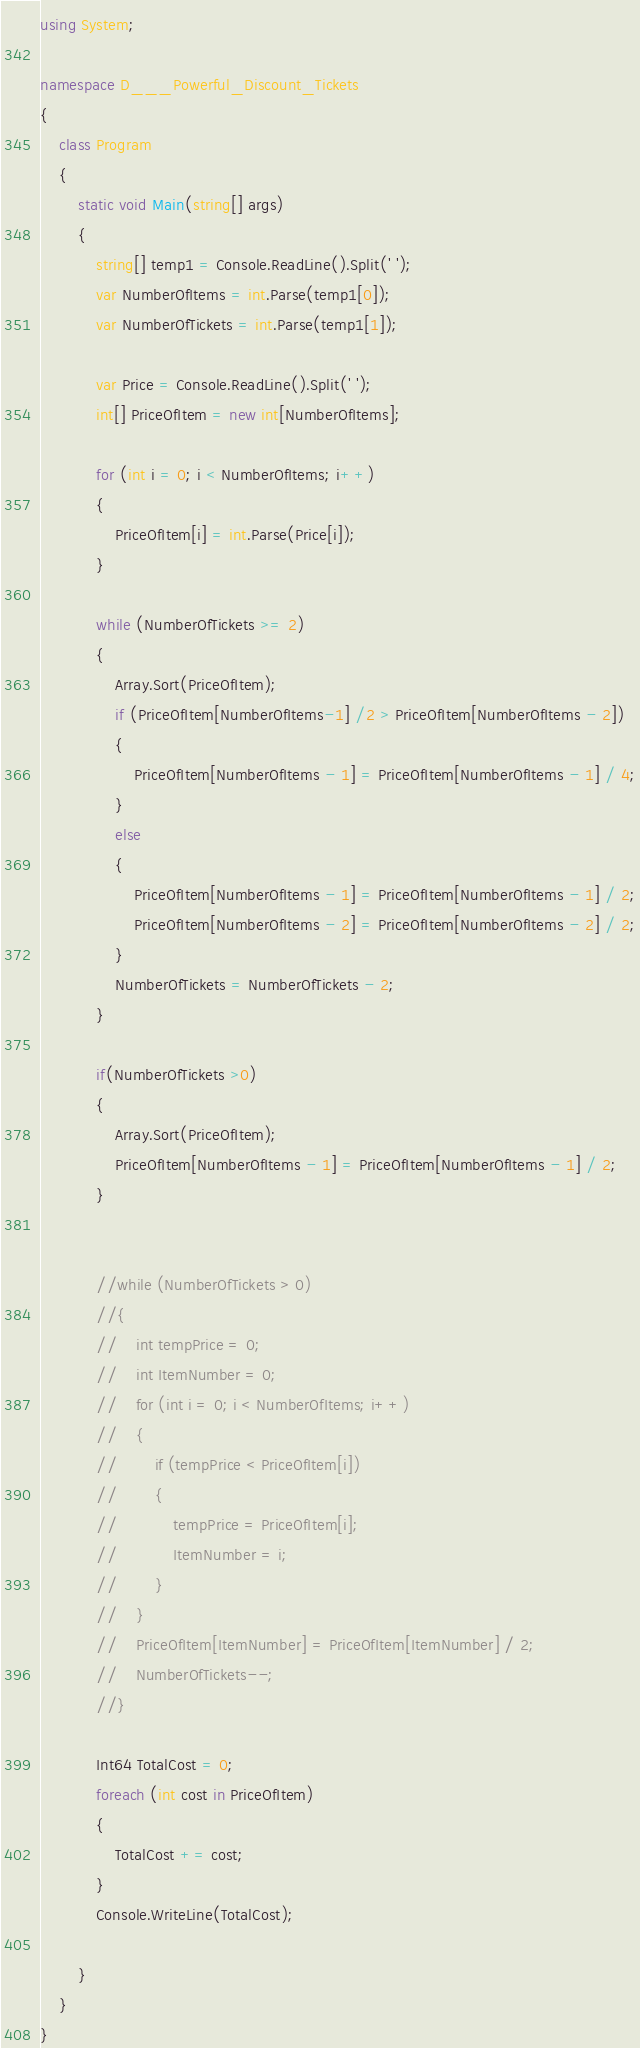Convert code to text. <code><loc_0><loc_0><loc_500><loc_500><_C#_>using System;

namespace D___Powerful_Discount_Tickets
{
    class Program
    {
        static void Main(string[] args)
        {
            string[] temp1 = Console.ReadLine().Split(' ');
            var NumberOfItems = int.Parse(temp1[0]);
            var NumberOfTickets = int.Parse(temp1[1]);

            var Price = Console.ReadLine().Split(' ');
            int[] PriceOfItem = new int[NumberOfItems];

            for (int i = 0; i < NumberOfItems; i++)
            {
                PriceOfItem[i] = int.Parse(Price[i]);
            }

            while (NumberOfTickets >= 2)
            {
                Array.Sort(PriceOfItem);
                if (PriceOfItem[NumberOfItems-1] /2 > PriceOfItem[NumberOfItems - 2])
                {
                    PriceOfItem[NumberOfItems - 1] = PriceOfItem[NumberOfItems - 1] / 4;
                }
                else
                {
                    PriceOfItem[NumberOfItems - 1] = PriceOfItem[NumberOfItems - 1] / 2;
                    PriceOfItem[NumberOfItems - 2] = PriceOfItem[NumberOfItems - 2] / 2;
                }
                NumberOfTickets = NumberOfTickets - 2;
            }

            if(NumberOfTickets >0)
            {
                Array.Sort(PriceOfItem);
                PriceOfItem[NumberOfItems - 1] = PriceOfItem[NumberOfItems - 1] / 2;
            }


            //while (NumberOfTickets > 0)
            //{
            //    int tempPrice = 0;
            //    int ItemNumber = 0;
            //    for (int i = 0; i < NumberOfItems; i++)
            //    {
            //        if (tempPrice < PriceOfItem[i])
            //        {
            //            tempPrice = PriceOfItem[i];
            //            ItemNumber = i;
            //        }
            //    }
            //    PriceOfItem[ItemNumber] = PriceOfItem[ItemNumber] / 2;
            //    NumberOfTickets--;
            //}

            Int64 TotalCost = 0;
            foreach (int cost in PriceOfItem)
            {
                TotalCost += cost;
            }
            Console.WriteLine(TotalCost);

        }
    }
}
</code> 